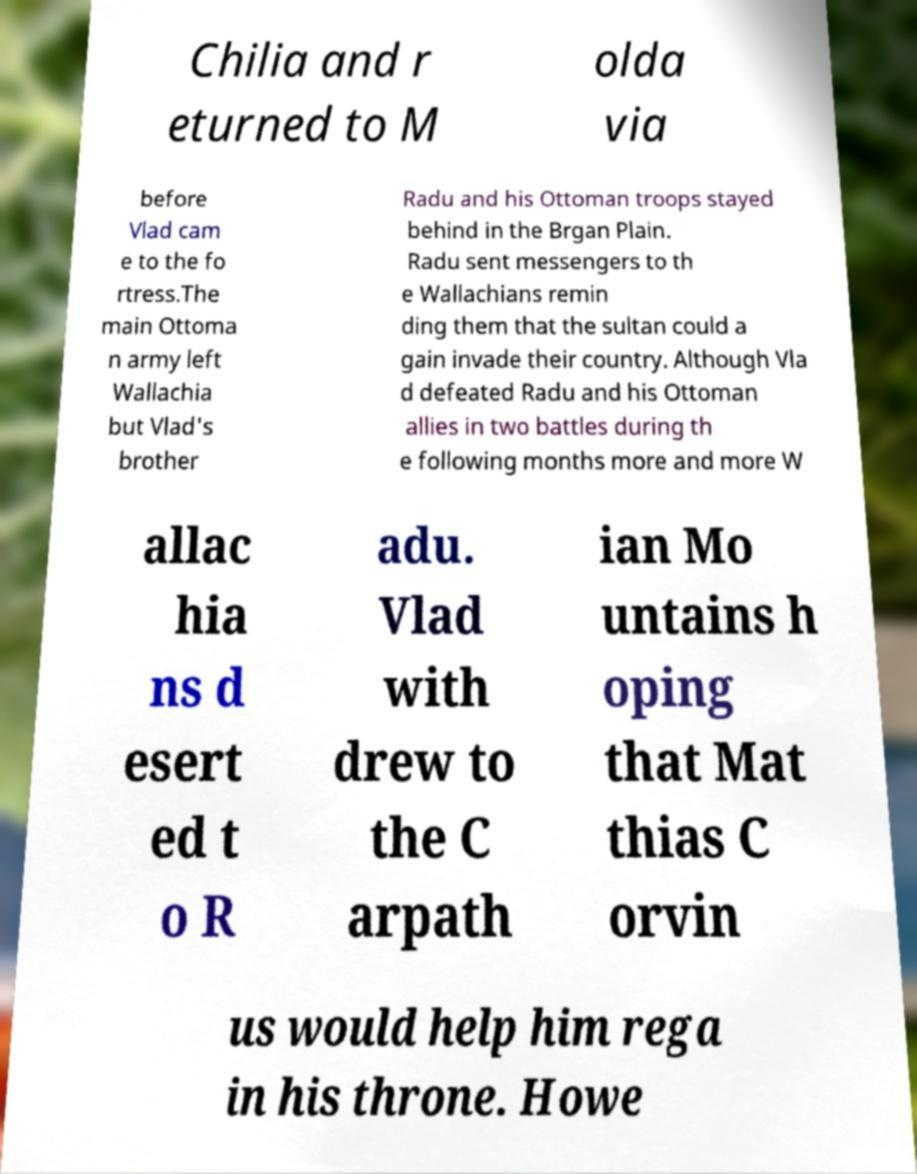What messages or text are displayed in this image? I need them in a readable, typed format. Chilia and r eturned to M olda via before Vlad cam e to the fo rtress.The main Ottoma n army left Wallachia but Vlad's brother Radu and his Ottoman troops stayed behind in the Brgan Plain. Radu sent messengers to th e Wallachians remin ding them that the sultan could a gain invade their country. Although Vla d defeated Radu and his Ottoman allies in two battles during th e following months more and more W allac hia ns d esert ed t o R adu. Vlad with drew to the C arpath ian Mo untains h oping that Mat thias C orvin us would help him rega in his throne. Howe 